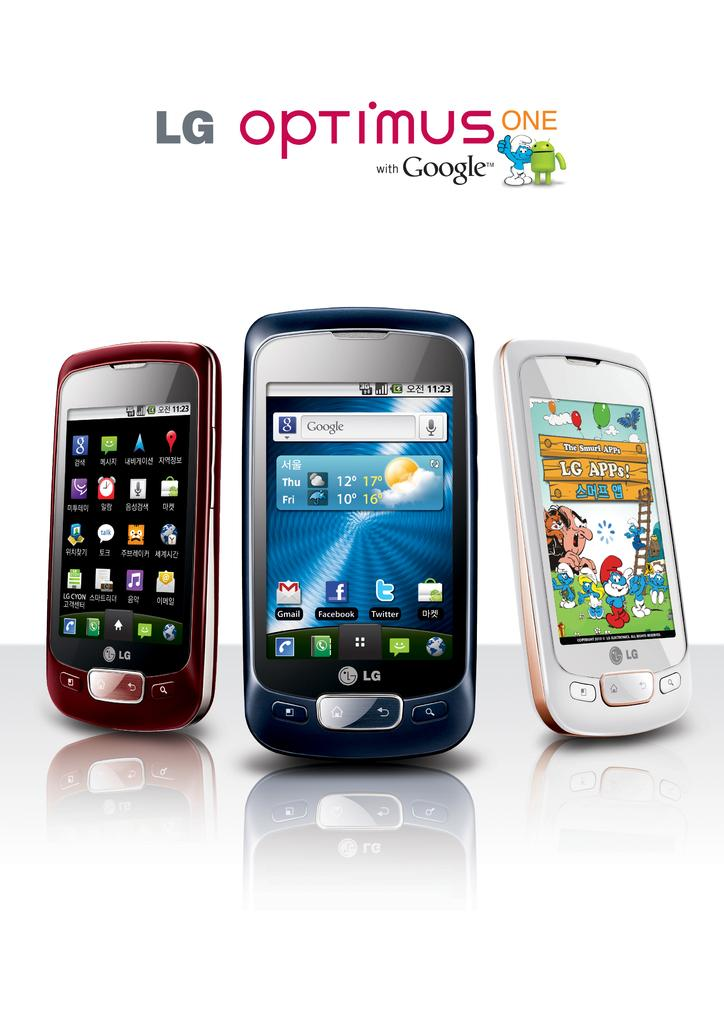Provide a one-sentence caption for the provided image. Three cellphones models from LG are named optimus one. 